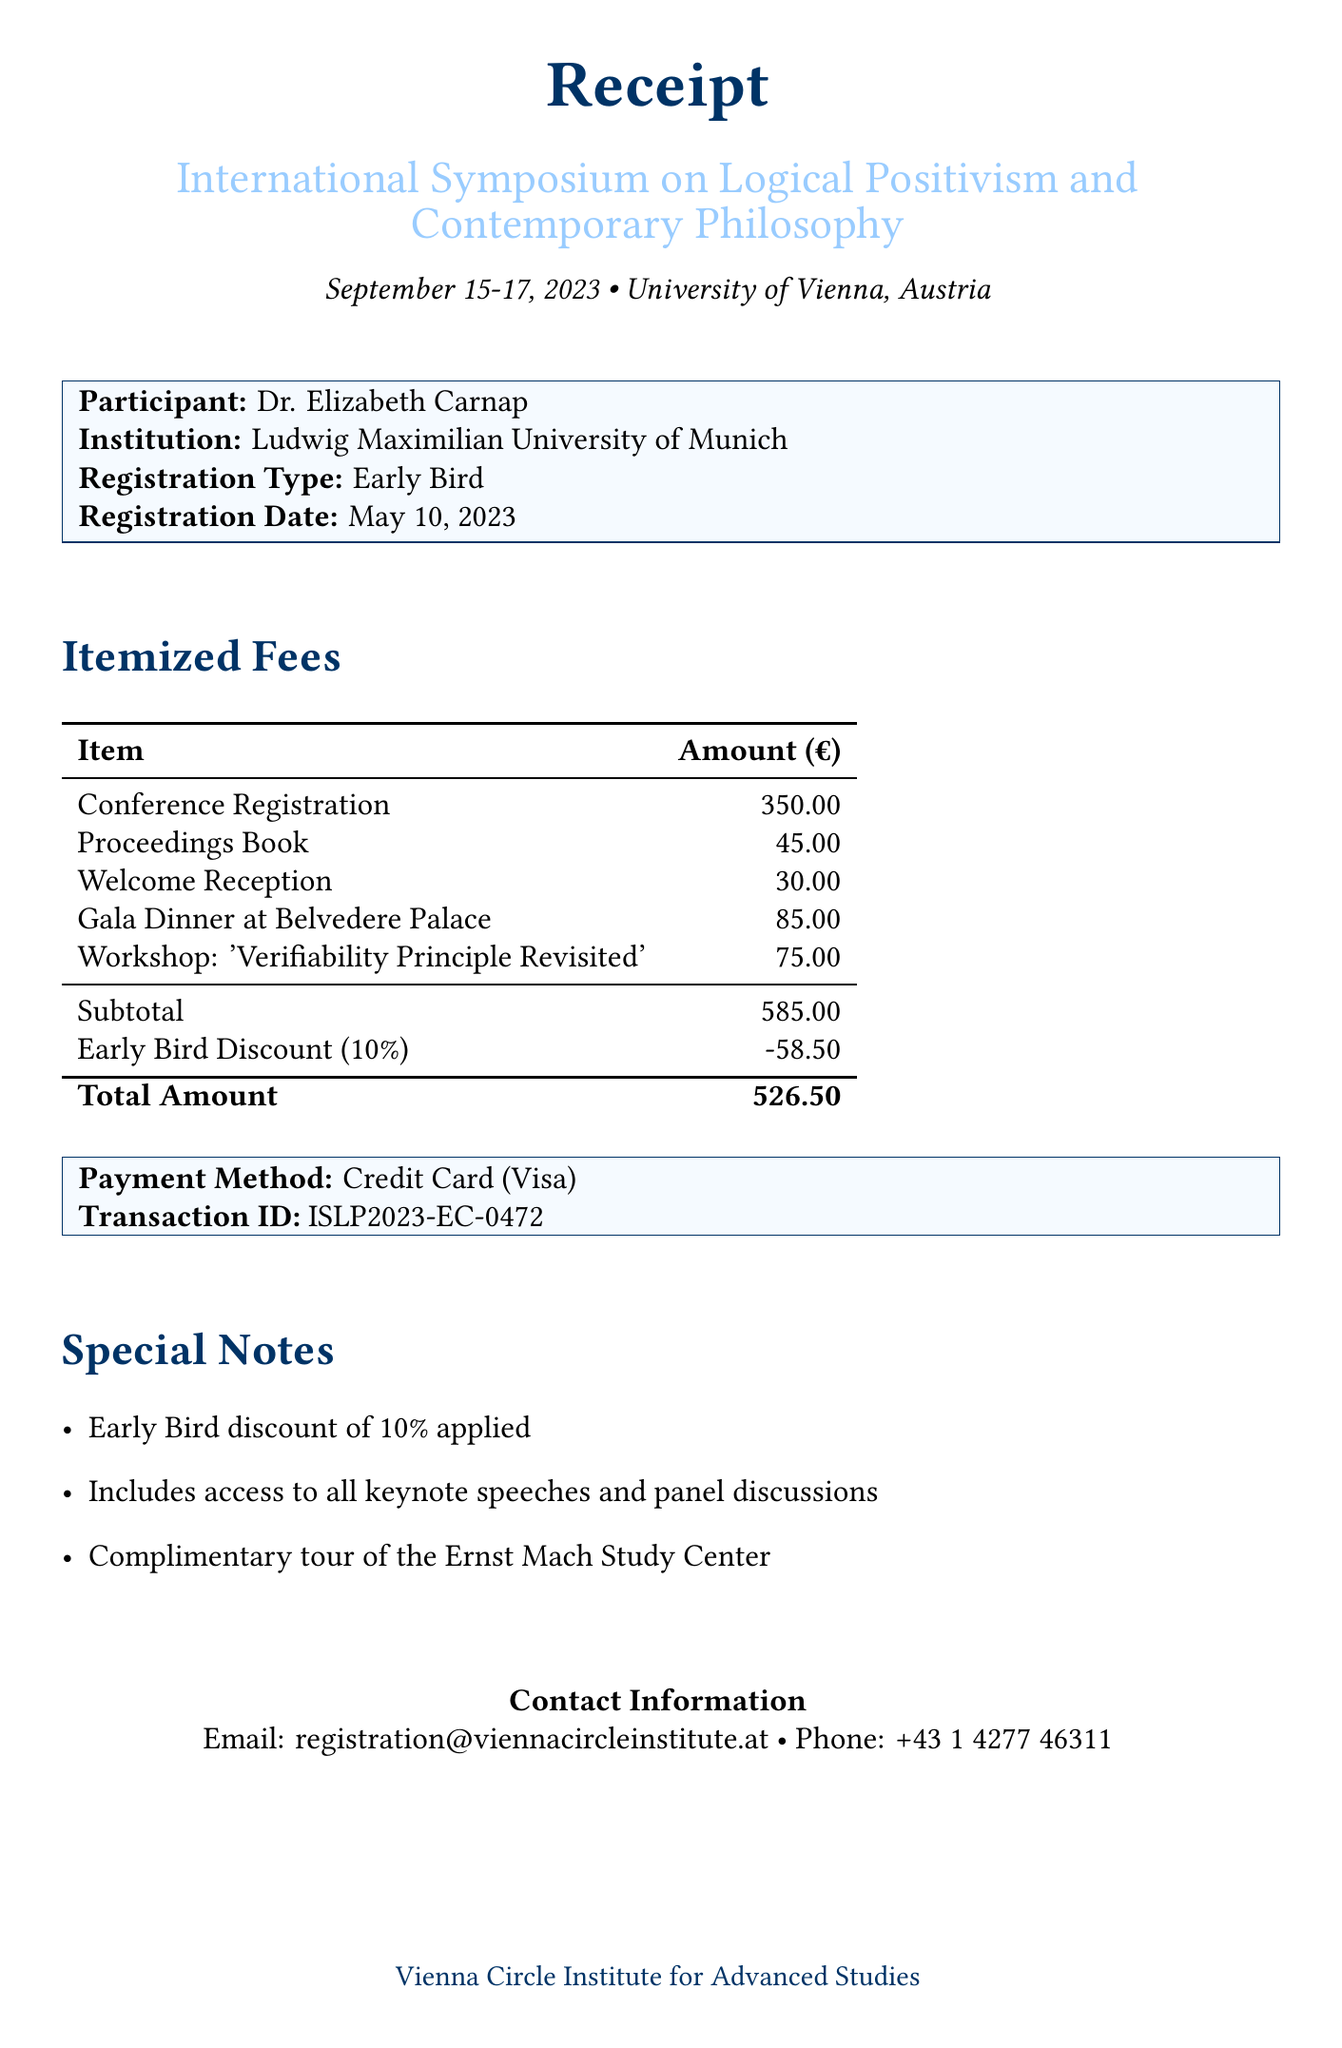What is the conference name? The conference name is explicitly mentioned at the top of the document, referring to the event that the registration pertains to.
Answer: International Symposium on Logical Positivism and Contemporary Philosophy What is the registration type? The registration type indicates whether the participant registered at the early bird rate or another category, which is clearly stated in the participant details section.
Answer: Early Bird What is the total amount due? The total amount is calculated after applying the early bird discount to the subtotal, summarizing the financial aspect of the registration.
Answer: 526.50 Who is the participant? The participant’s name is stated prominently in the details, allowing for easy identification of the individual registering for the conference.
Answer: Dr. Elizabeth Carnap What discount was applied? The document notes the percentage discount applied to the subtotal, which is an important detail relevant to the cost of registration.
Answer: 10% Where was the conference held? The venue is specified in the document, making it clear where the event took place.
Answer: University of Vienna, Austria What is the payment method used? The payment method clearly specifies how the participant paid for their registration, which is a typical detail in receipts.
Answer: Credit Card (Visa) What is the transaction ID? The transaction ID is a unique identifier for the payment, provided in the payment details section for reference.
Answer: ISLP2023-EC-0472 What will the participant receive access to? The document outlines additional benefits of registration, specifying what is included beyond the basic registration.
Answer: All keynote speeches and panel discussions 